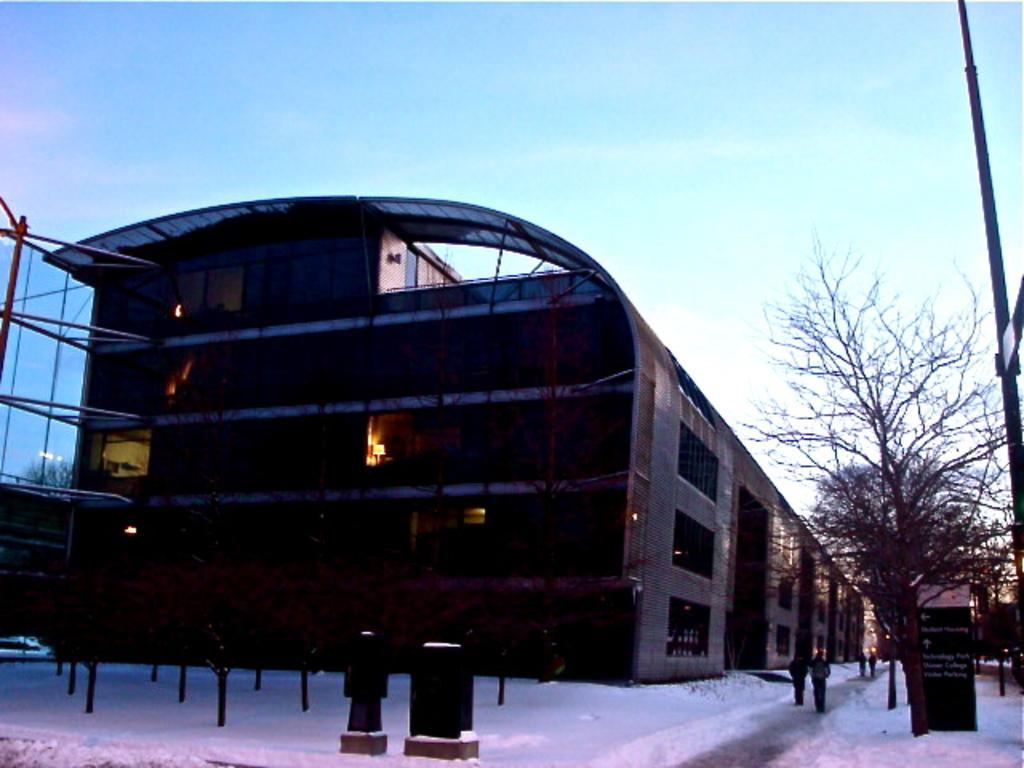Can you describe this image briefly? In this image in the middle, there is a building. At the bottom there are some people, poles and ice. On the right there are trees, poster, poles, sign boards, sky. 